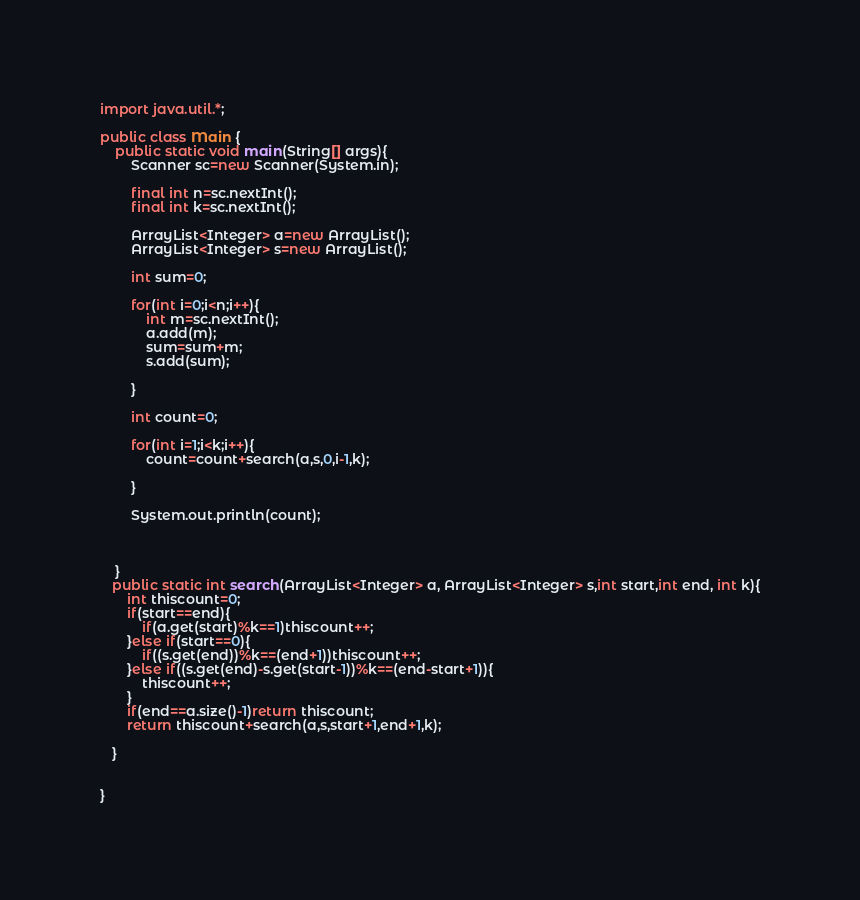Convert code to text. <code><loc_0><loc_0><loc_500><loc_500><_Java_>
import java.util.*;

public class Main {
	public static void main(String[] args){
		Scanner sc=new Scanner(System.in);
		
		final int n=sc.nextInt();
		final int k=sc.nextInt();
		
		ArrayList<Integer> a=new ArrayList();
		ArrayList<Integer> s=new ArrayList();
		
		int sum=0;
		
		for(int i=0;i<n;i++){
			int m=sc.nextInt();
			a.add(m);
			sum=sum+m;
			s.add(sum);
			
		}
		
		int count=0;
		
		for(int i=1;i<k;i++){
			count=count+search(a,s,0,i-1,k);
			
		}
		
		System.out.println(count);
		
		
		
	}
   public static int search(ArrayList<Integer> a, ArrayList<Integer> s,int start,int end, int k){
	   int thiscount=0;
	   if(start==end){
		   if(a.get(start)%k==1)thiscount++;
	   }else if(start==0){
		   if((s.get(end))%k==(end+1))thiscount++;
	   }else if((s.get(end)-s.get(start-1))%k==(end-start+1)){
		   thiscount++;
	   }
	   if(end==a.size()-1)return thiscount;
	   return thiscount+search(a,s,start+1,end+1,k);
	  
   }
	

}
</code> 